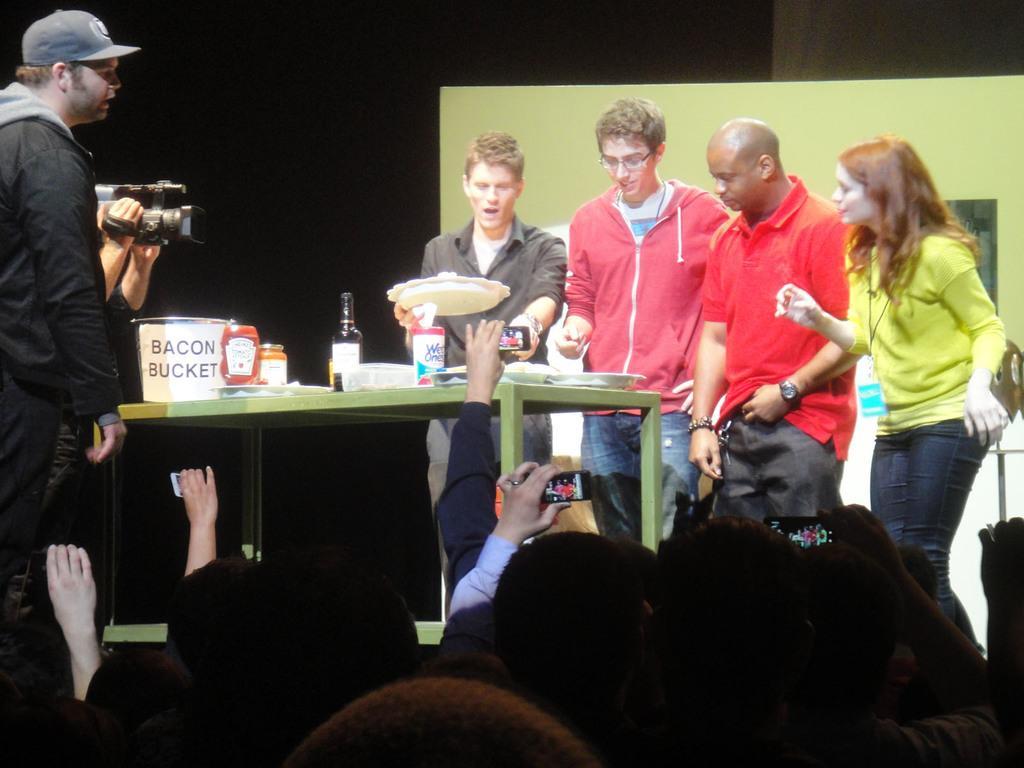Can you describe this image briefly? Here we can see few persons and they are holding mobiles. This is table. On the table there is a bored, jar, bottle, and plates. Here we can see a person holding a camera. There is a banner and there is a dark background. 